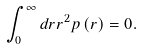Convert formula to latex. <formula><loc_0><loc_0><loc_500><loc_500>\int \nolimits _ { 0 } ^ { \infty } d r r ^ { 2 } p \left ( r \right ) = 0 .</formula> 